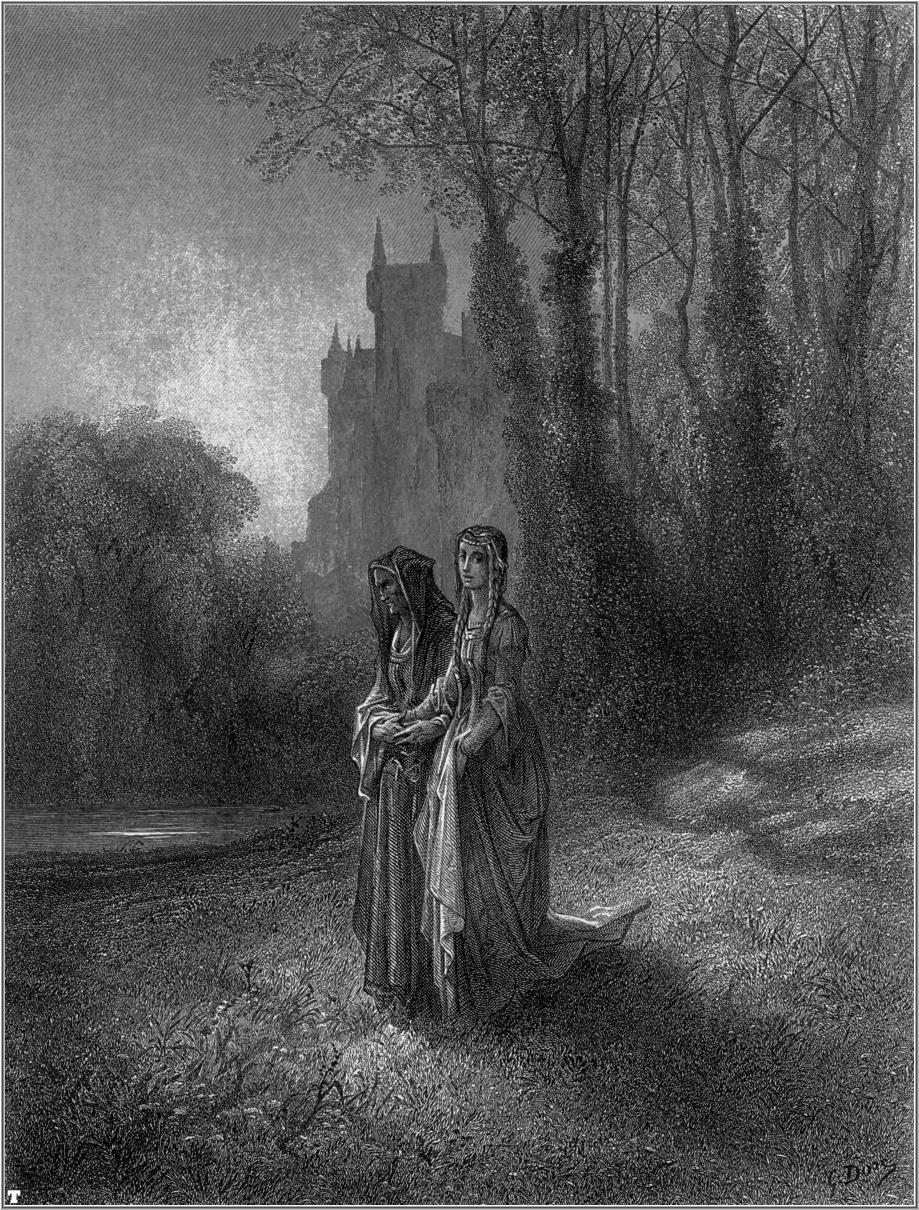Imagine the story behind the two women and the castle. What brought them there? The two women in the illustration are sisters, who once lived in the grand castle that now stands as a silent guardian in the distance. Born to a noble family, their days were filled with the responsibilities of court life. However, they found solace in the simplicity of the surrounding forest. It was their secret haven, a place where they could escape the formality of their station and embrace the serenity of nature.

Years passed, and turmoil struck their homeland. An invasion forced their family to abandon the castle. The sisters vowed to return one day, to reclaim their heritage and restore the castle to its former glory. Now, they walk the forest in quiet reflection, gathering their strength and planning their next move.

The basket held by one sister contains medicinal herbs and foraged food, as they have learned to live off the land in these troubled times. Their gaze is not only toward the flora around them but also fixed on the castle, representing a bastion of hope and a future they are determined to rebuild. 